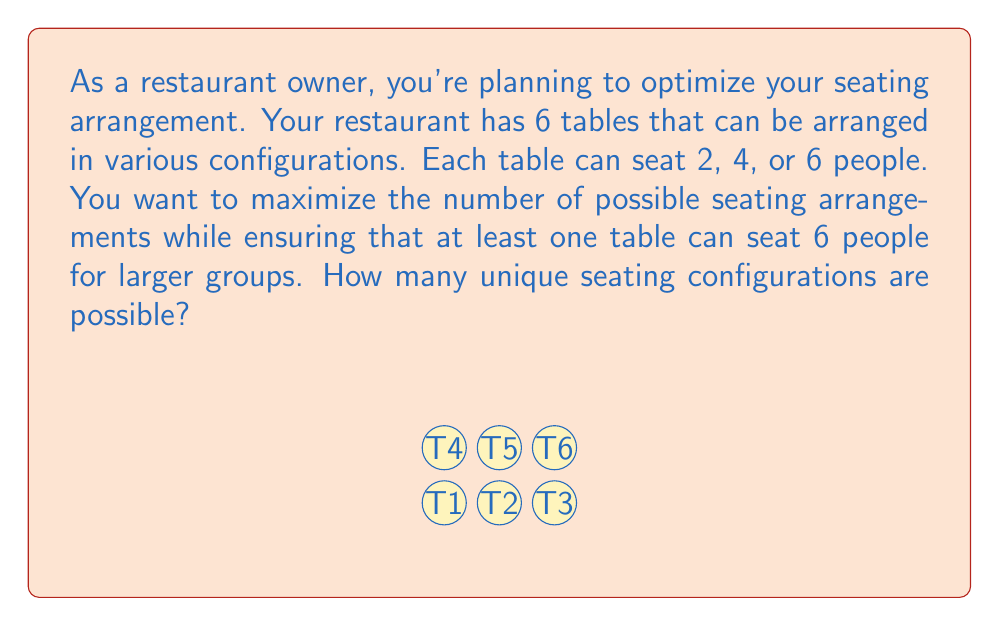What is the answer to this math problem? Let's approach this step-by-step using combinatorics:

1) We have 6 tables, each with 3 possible seating options (2, 4, or 6 people).

2) Without any restrictions, the total number of configurations would be $3^6 = 729$, as each table has 3 choices, and we have 6 independent choices.

3) However, we need to ensure at least one table seats 6 people. To calculate this, we can use the principle of inclusion-exclusion:

   (Total configurations) - (Configurations with no 6-seater tables)

4) Configurations with no 6-seater tables: Each table now has only 2 choices (2 or 4 people), so there are $2^6 = 64$ such configurations.

5) Therefore, the number of valid configurations is:

   $$ 3^6 - 2^6 = 729 - 64 = 665 $$

This approach ensures we count all configurations with at least one 6-seater table, which satisfies our requirement for larger groups while maximizing seating flexibility.
Answer: 665 unique seating configurations 